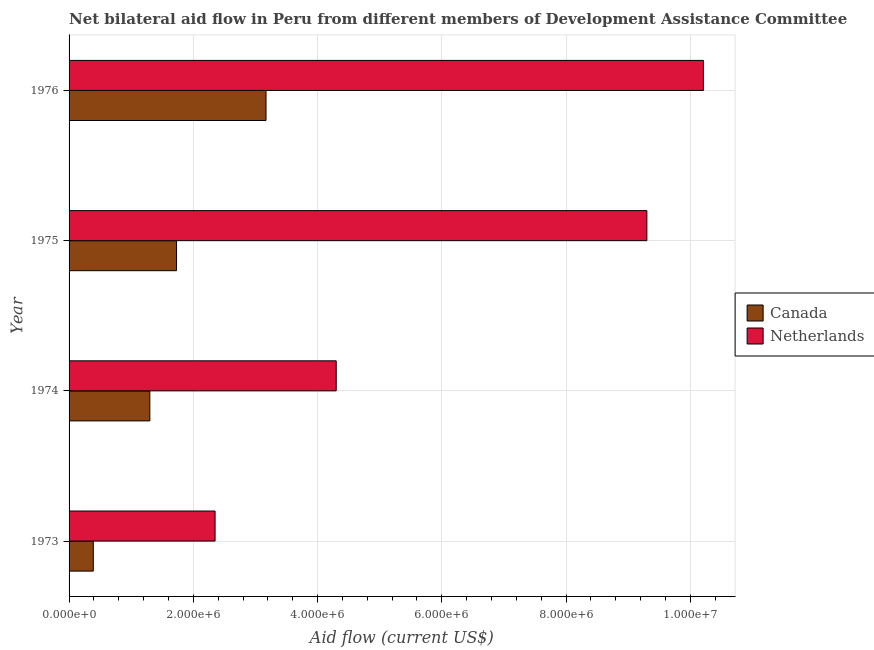How many different coloured bars are there?
Provide a succinct answer. 2. Are the number of bars on each tick of the Y-axis equal?
Your answer should be compact. Yes. How many bars are there on the 3rd tick from the top?
Your answer should be compact. 2. How many bars are there on the 3rd tick from the bottom?
Ensure brevity in your answer.  2. In how many cases, is the number of bars for a given year not equal to the number of legend labels?
Ensure brevity in your answer.  0. What is the amount of aid given by canada in 1973?
Give a very brief answer. 3.90e+05. Across all years, what is the maximum amount of aid given by netherlands?
Offer a very short reply. 1.02e+07. Across all years, what is the minimum amount of aid given by canada?
Your response must be concise. 3.90e+05. In which year was the amount of aid given by canada maximum?
Offer a very short reply. 1976. In which year was the amount of aid given by canada minimum?
Give a very brief answer. 1973. What is the total amount of aid given by canada in the graph?
Keep it short and to the point. 6.59e+06. What is the difference between the amount of aid given by canada in 1974 and that in 1976?
Keep it short and to the point. -1.87e+06. What is the difference between the amount of aid given by canada in 1975 and the amount of aid given by netherlands in 1973?
Keep it short and to the point. -6.20e+05. What is the average amount of aid given by netherlands per year?
Offer a very short reply. 6.54e+06. In the year 1976, what is the difference between the amount of aid given by canada and amount of aid given by netherlands?
Keep it short and to the point. -7.04e+06. In how many years, is the amount of aid given by netherlands greater than 800000 US$?
Ensure brevity in your answer.  4. What is the ratio of the amount of aid given by netherlands in 1974 to that in 1975?
Offer a terse response. 0.46. Is the amount of aid given by canada in 1975 less than that in 1976?
Keep it short and to the point. Yes. Is the difference between the amount of aid given by canada in 1973 and 1975 greater than the difference between the amount of aid given by netherlands in 1973 and 1975?
Give a very brief answer. Yes. What is the difference between the highest and the second highest amount of aid given by canada?
Keep it short and to the point. 1.44e+06. What is the difference between the highest and the lowest amount of aid given by netherlands?
Keep it short and to the point. 7.86e+06. What does the 2nd bar from the top in 1974 represents?
Offer a terse response. Canada. How many bars are there?
Your answer should be very brief. 8. How many years are there in the graph?
Make the answer very short. 4. What is the difference between two consecutive major ticks on the X-axis?
Give a very brief answer. 2.00e+06. Does the graph contain grids?
Your response must be concise. Yes. How many legend labels are there?
Ensure brevity in your answer.  2. What is the title of the graph?
Give a very brief answer. Net bilateral aid flow in Peru from different members of Development Assistance Committee. Does "Infant" appear as one of the legend labels in the graph?
Ensure brevity in your answer.  No. What is the Aid flow (current US$) of Canada in 1973?
Provide a short and direct response. 3.90e+05. What is the Aid flow (current US$) of Netherlands in 1973?
Your response must be concise. 2.35e+06. What is the Aid flow (current US$) of Canada in 1974?
Provide a succinct answer. 1.30e+06. What is the Aid flow (current US$) in Netherlands in 1974?
Make the answer very short. 4.30e+06. What is the Aid flow (current US$) of Canada in 1975?
Your answer should be very brief. 1.73e+06. What is the Aid flow (current US$) of Netherlands in 1975?
Provide a short and direct response. 9.30e+06. What is the Aid flow (current US$) in Canada in 1976?
Ensure brevity in your answer.  3.17e+06. What is the Aid flow (current US$) in Netherlands in 1976?
Keep it short and to the point. 1.02e+07. Across all years, what is the maximum Aid flow (current US$) in Canada?
Offer a terse response. 3.17e+06. Across all years, what is the maximum Aid flow (current US$) of Netherlands?
Ensure brevity in your answer.  1.02e+07. Across all years, what is the minimum Aid flow (current US$) in Netherlands?
Your response must be concise. 2.35e+06. What is the total Aid flow (current US$) of Canada in the graph?
Ensure brevity in your answer.  6.59e+06. What is the total Aid flow (current US$) of Netherlands in the graph?
Make the answer very short. 2.62e+07. What is the difference between the Aid flow (current US$) of Canada in 1973 and that in 1974?
Keep it short and to the point. -9.10e+05. What is the difference between the Aid flow (current US$) in Netherlands in 1973 and that in 1974?
Offer a very short reply. -1.95e+06. What is the difference between the Aid flow (current US$) of Canada in 1973 and that in 1975?
Make the answer very short. -1.34e+06. What is the difference between the Aid flow (current US$) in Netherlands in 1973 and that in 1975?
Offer a terse response. -6.95e+06. What is the difference between the Aid flow (current US$) in Canada in 1973 and that in 1976?
Your response must be concise. -2.78e+06. What is the difference between the Aid flow (current US$) of Netherlands in 1973 and that in 1976?
Make the answer very short. -7.86e+06. What is the difference between the Aid flow (current US$) in Canada in 1974 and that in 1975?
Offer a very short reply. -4.30e+05. What is the difference between the Aid flow (current US$) in Netherlands in 1974 and that in 1975?
Offer a very short reply. -5.00e+06. What is the difference between the Aid flow (current US$) in Canada in 1974 and that in 1976?
Offer a very short reply. -1.87e+06. What is the difference between the Aid flow (current US$) of Netherlands in 1974 and that in 1976?
Provide a short and direct response. -5.91e+06. What is the difference between the Aid flow (current US$) in Canada in 1975 and that in 1976?
Give a very brief answer. -1.44e+06. What is the difference between the Aid flow (current US$) in Netherlands in 1975 and that in 1976?
Provide a succinct answer. -9.10e+05. What is the difference between the Aid flow (current US$) of Canada in 1973 and the Aid flow (current US$) of Netherlands in 1974?
Your response must be concise. -3.91e+06. What is the difference between the Aid flow (current US$) of Canada in 1973 and the Aid flow (current US$) of Netherlands in 1975?
Make the answer very short. -8.91e+06. What is the difference between the Aid flow (current US$) of Canada in 1973 and the Aid flow (current US$) of Netherlands in 1976?
Provide a succinct answer. -9.82e+06. What is the difference between the Aid flow (current US$) of Canada in 1974 and the Aid flow (current US$) of Netherlands in 1975?
Your answer should be very brief. -8.00e+06. What is the difference between the Aid flow (current US$) of Canada in 1974 and the Aid flow (current US$) of Netherlands in 1976?
Offer a very short reply. -8.91e+06. What is the difference between the Aid flow (current US$) in Canada in 1975 and the Aid flow (current US$) in Netherlands in 1976?
Your answer should be very brief. -8.48e+06. What is the average Aid flow (current US$) of Canada per year?
Your response must be concise. 1.65e+06. What is the average Aid flow (current US$) in Netherlands per year?
Ensure brevity in your answer.  6.54e+06. In the year 1973, what is the difference between the Aid flow (current US$) of Canada and Aid flow (current US$) of Netherlands?
Your answer should be compact. -1.96e+06. In the year 1974, what is the difference between the Aid flow (current US$) in Canada and Aid flow (current US$) in Netherlands?
Make the answer very short. -3.00e+06. In the year 1975, what is the difference between the Aid flow (current US$) in Canada and Aid flow (current US$) in Netherlands?
Provide a short and direct response. -7.57e+06. In the year 1976, what is the difference between the Aid flow (current US$) of Canada and Aid flow (current US$) of Netherlands?
Provide a short and direct response. -7.04e+06. What is the ratio of the Aid flow (current US$) of Netherlands in 1973 to that in 1974?
Ensure brevity in your answer.  0.55. What is the ratio of the Aid flow (current US$) of Canada in 1973 to that in 1975?
Your response must be concise. 0.23. What is the ratio of the Aid flow (current US$) of Netherlands in 1973 to that in 1975?
Give a very brief answer. 0.25. What is the ratio of the Aid flow (current US$) of Canada in 1973 to that in 1976?
Make the answer very short. 0.12. What is the ratio of the Aid flow (current US$) of Netherlands in 1973 to that in 1976?
Provide a succinct answer. 0.23. What is the ratio of the Aid flow (current US$) of Canada in 1974 to that in 1975?
Make the answer very short. 0.75. What is the ratio of the Aid flow (current US$) in Netherlands in 1974 to that in 1975?
Ensure brevity in your answer.  0.46. What is the ratio of the Aid flow (current US$) of Canada in 1974 to that in 1976?
Your response must be concise. 0.41. What is the ratio of the Aid flow (current US$) of Netherlands in 1974 to that in 1976?
Your answer should be compact. 0.42. What is the ratio of the Aid flow (current US$) of Canada in 1975 to that in 1976?
Give a very brief answer. 0.55. What is the ratio of the Aid flow (current US$) in Netherlands in 1975 to that in 1976?
Provide a short and direct response. 0.91. What is the difference between the highest and the second highest Aid flow (current US$) of Canada?
Offer a very short reply. 1.44e+06. What is the difference between the highest and the second highest Aid flow (current US$) of Netherlands?
Make the answer very short. 9.10e+05. What is the difference between the highest and the lowest Aid flow (current US$) of Canada?
Your response must be concise. 2.78e+06. What is the difference between the highest and the lowest Aid flow (current US$) of Netherlands?
Your response must be concise. 7.86e+06. 